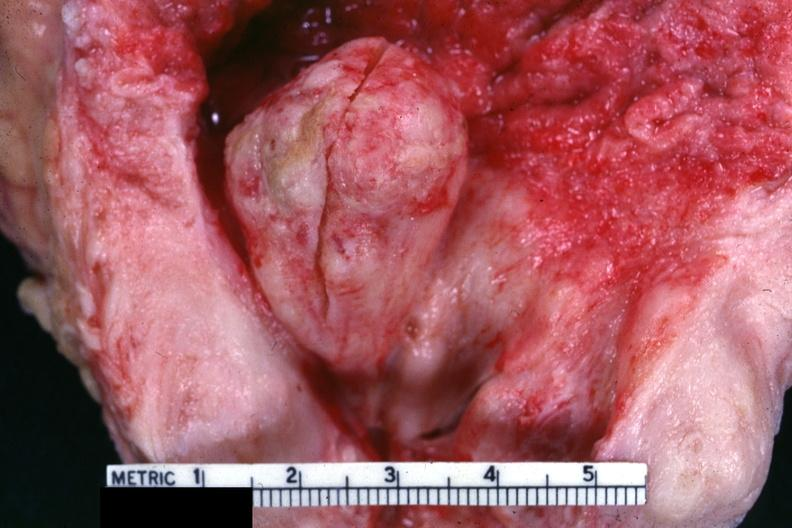what is present?
Answer the question using a single word or phrase. Hyperplasia 